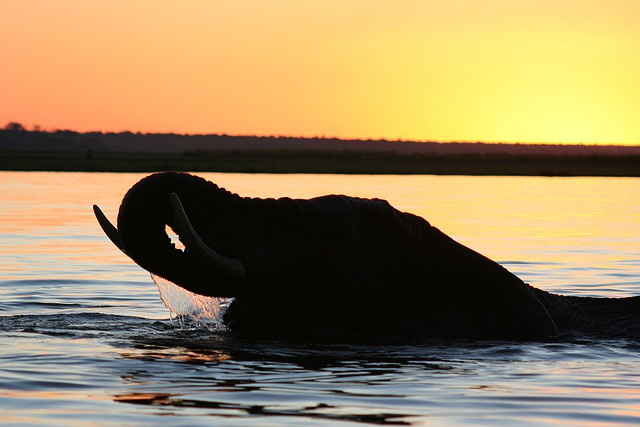Describe the objects in this image and their specific colors. I can see a elephant in tan, black, maroon, and brown tones in this image. 